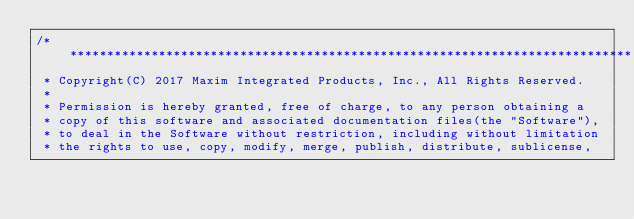<code> <loc_0><loc_0><loc_500><loc_500><_C_>/* ****************************************************************************
 * Copyright(C) 2017 Maxim Integrated Products, Inc., All Rights Reserved.
 *
 * Permission is hereby granted, free of charge, to any person obtaining a
 * copy of this software and associated documentation files(the "Software"), 
 * to deal in the Software without restriction, including without limitation
 * the rights to use, copy, modify, merge, publish, distribute, sublicense, </code> 